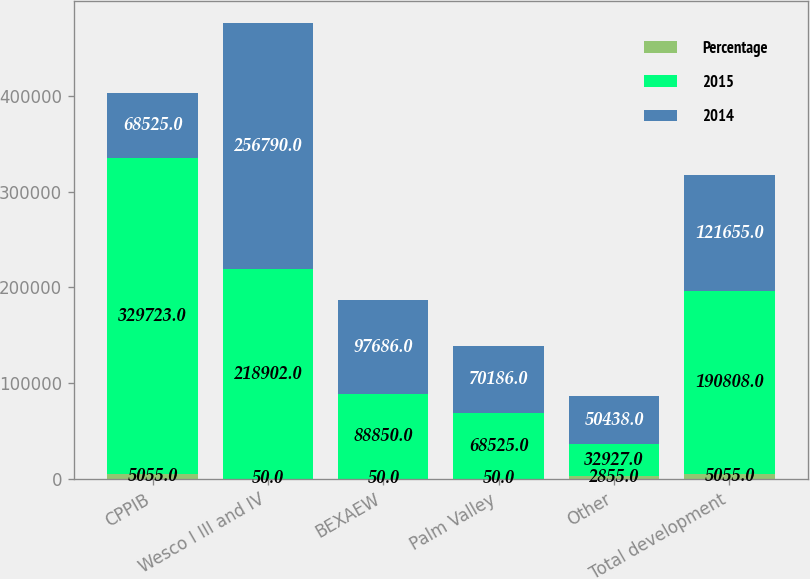Convert chart. <chart><loc_0><loc_0><loc_500><loc_500><stacked_bar_chart><ecel><fcel>CPPIB<fcel>Wesco I III and IV<fcel>BEXAEW<fcel>Palm Valley<fcel>Other<fcel>Total development<nl><fcel>Percentage<fcel>5055<fcel>50<fcel>50<fcel>50<fcel>2855<fcel>5055<nl><fcel>2015<fcel>329723<fcel>218902<fcel>88850<fcel>68525<fcel>32927<fcel>190808<nl><fcel>2014<fcel>68525<fcel>256790<fcel>97686<fcel>70186<fcel>50438<fcel>121655<nl></chart> 